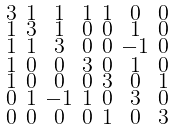Convert formula to latex. <formula><loc_0><loc_0><loc_500><loc_500>\begin{smallmatrix} 3 & 1 & 1 & 1 & 1 & 0 & 0 \\ 1 & 3 & 1 & 0 & 0 & 1 & 0 \\ 1 & 1 & 3 & 0 & 0 & - 1 & 0 \\ 1 & 0 & 0 & 3 & 0 & 1 & 0 \\ 1 & 0 & 0 & 0 & 3 & 0 & 1 \\ 0 & 1 & - 1 & 1 & 0 & 3 & 0 \\ 0 & 0 & 0 & 0 & 1 & 0 & 3 \end{smallmatrix}</formula> 